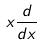Convert formula to latex. <formula><loc_0><loc_0><loc_500><loc_500>x \frac { d } { d x }</formula> 